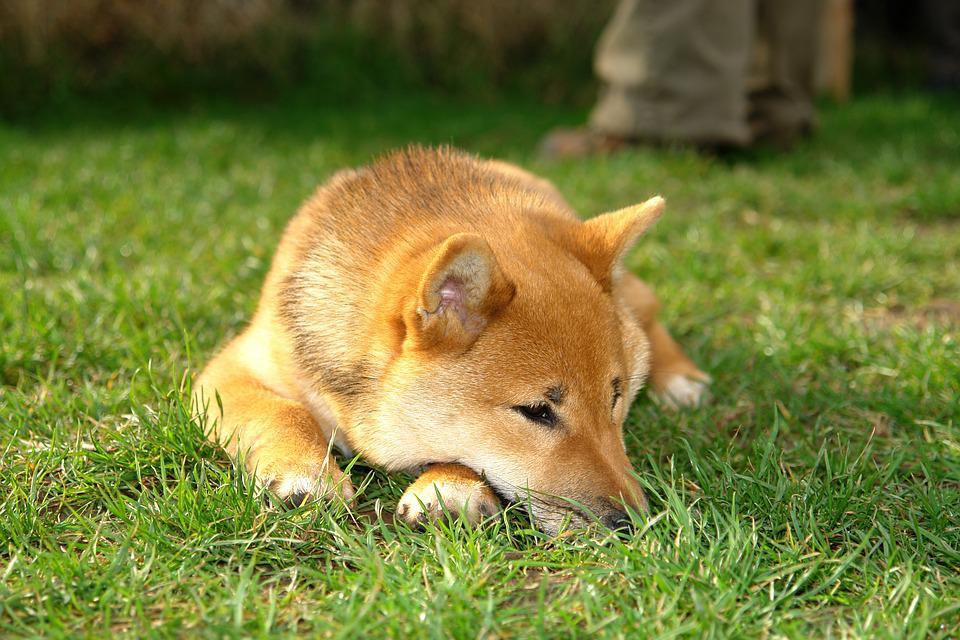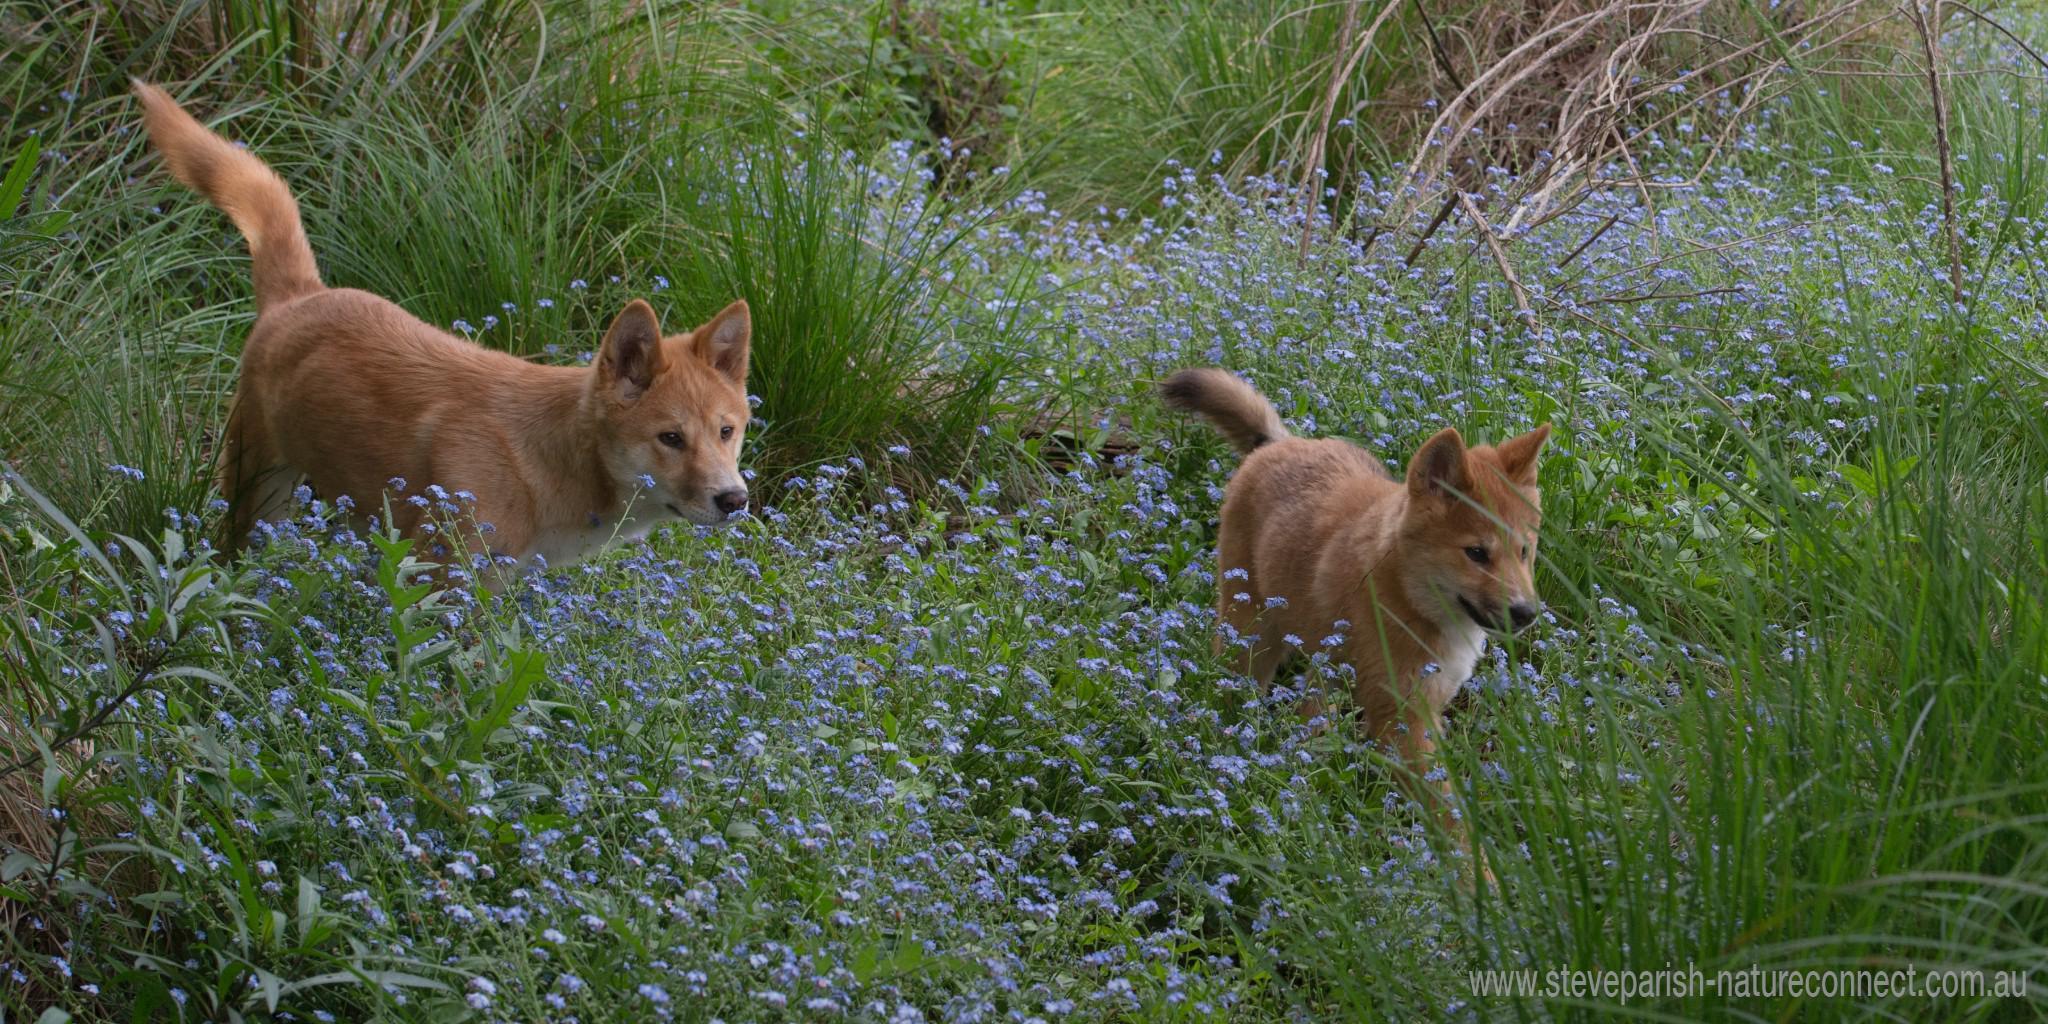The first image is the image on the left, the second image is the image on the right. Examine the images to the left and right. Is the description "There are two dogs in total." accurate? Answer yes or no. No. 